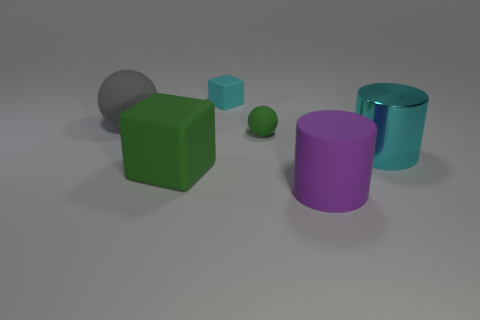Is there any other thing that has the same material as the large cyan cylinder?
Ensure brevity in your answer.  No. What number of things are both to the right of the gray matte sphere and to the left of the cyan shiny object?
Offer a terse response. 4. What number of large cyan metallic objects are the same shape as the big green matte thing?
Give a very brief answer. 0. There is a rubber sphere to the left of the block right of the large green matte object; what color is it?
Your answer should be very brief. Gray. There is a gray object; is it the same shape as the green thing that is on the right side of the large rubber cube?
Offer a terse response. Yes. What material is the cyan cylinder that is on the right side of the sphere that is right of the sphere left of the cyan matte block?
Your answer should be very brief. Metal. Are there any red balls of the same size as the gray object?
Ensure brevity in your answer.  No. There is a green cube that is the same material as the large purple object; what is its size?
Provide a short and direct response. Large. There is a large gray object; what shape is it?
Ensure brevity in your answer.  Sphere. Do the cyan cube and the sphere right of the big green rubber object have the same material?
Your answer should be compact. Yes. 